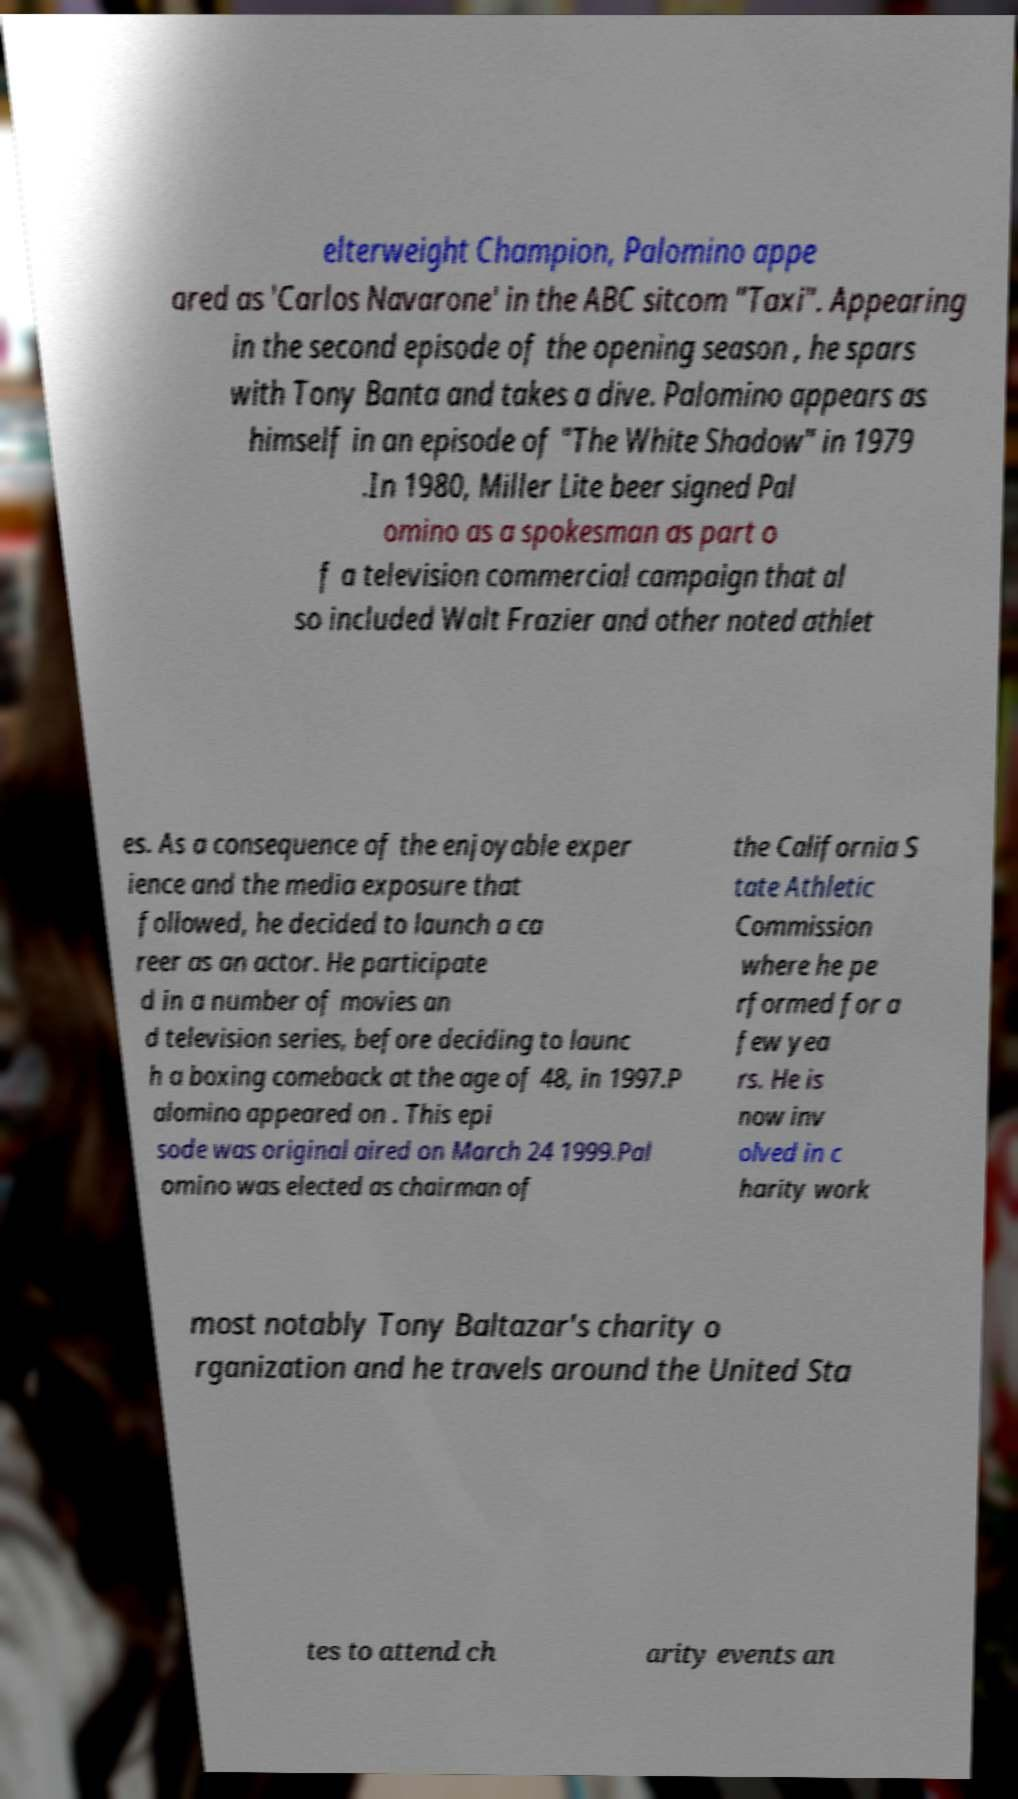What messages or text are displayed in this image? I need them in a readable, typed format. elterweight Champion, Palomino appe ared as 'Carlos Navarone' in the ABC sitcom "Taxi". Appearing in the second episode of the opening season , he spars with Tony Banta and takes a dive. Palomino appears as himself in an episode of "The White Shadow" in 1979 .In 1980, Miller Lite beer signed Pal omino as a spokesman as part o f a television commercial campaign that al so included Walt Frazier and other noted athlet es. As a consequence of the enjoyable exper ience and the media exposure that followed, he decided to launch a ca reer as an actor. He participate d in a number of movies an d television series, before deciding to launc h a boxing comeback at the age of 48, in 1997.P alomino appeared on . This epi sode was original aired on March 24 1999.Pal omino was elected as chairman of the California S tate Athletic Commission where he pe rformed for a few yea rs. He is now inv olved in c harity work most notably Tony Baltazar's charity o rganization and he travels around the United Sta tes to attend ch arity events an 